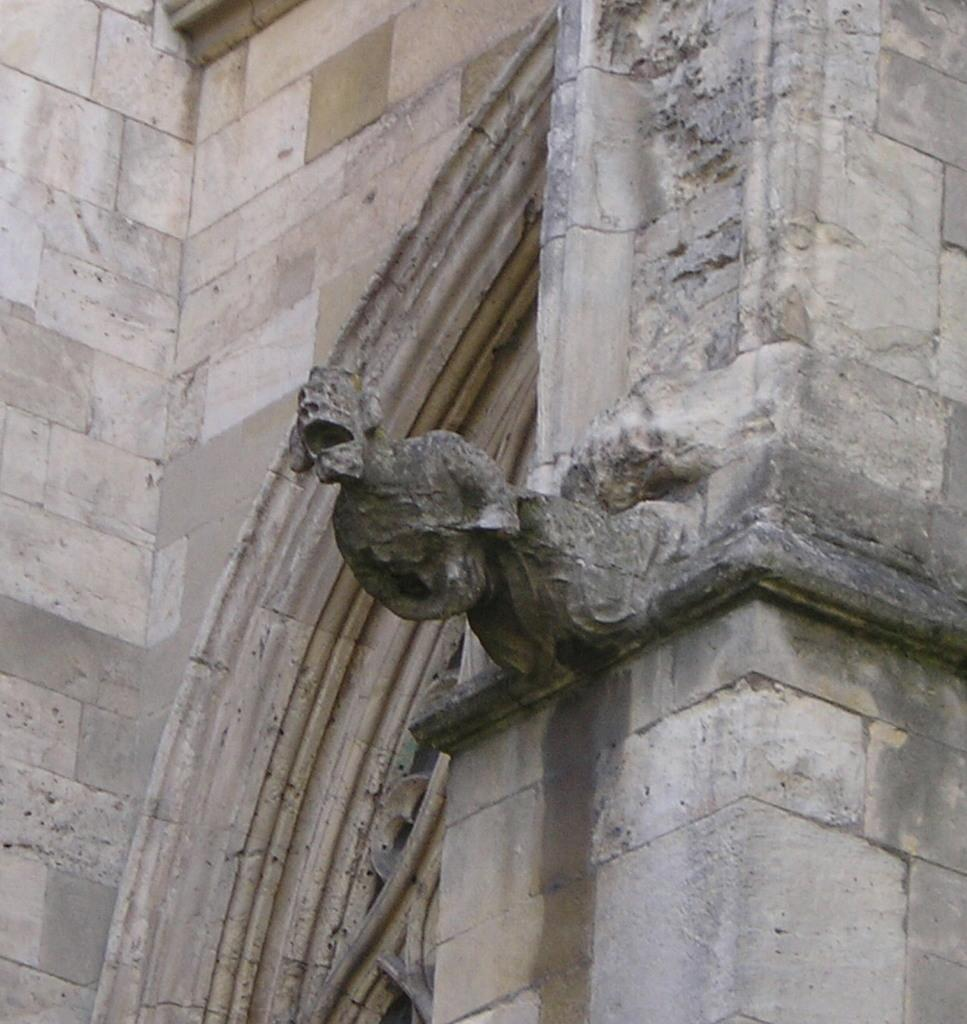What is the main subject in the middle of the image? There is a statue in the middle of the image. Can you describe the statue in more detail? The statue appears to be a construction. What type of wine is being served next to the statue in the image? There is no wine present in the image; it only features a statue. What advice is the statue giving to the people in the image? The statue is not giving any advice, as it is an inanimate object and cannot speak or provide advice. 